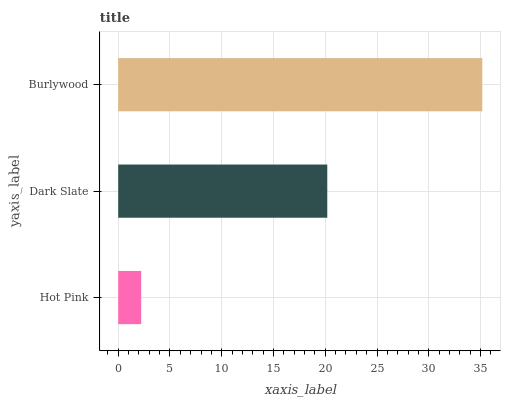Is Hot Pink the minimum?
Answer yes or no. Yes. Is Burlywood the maximum?
Answer yes or no. Yes. Is Dark Slate the minimum?
Answer yes or no. No. Is Dark Slate the maximum?
Answer yes or no. No. Is Dark Slate greater than Hot Pink?
Answer yes or no. Yes. Is Hot Pink less than Dark Slate?
Answer yes or no. Yes. Is Hot Pink greater than Dark Slate?
Answer yes or no. No. Is Dark Slate less than Hot Pink?
Answer yes or no. No. Is Dark Slate the high median?
Answer yes or no. Yes. Is Dark Slate the low median?
Answer yes or no. Yes. Is Burlywood the high median?
Answer yes or no. No. Is Burlywood the low median?
Answer yes or no. No. 